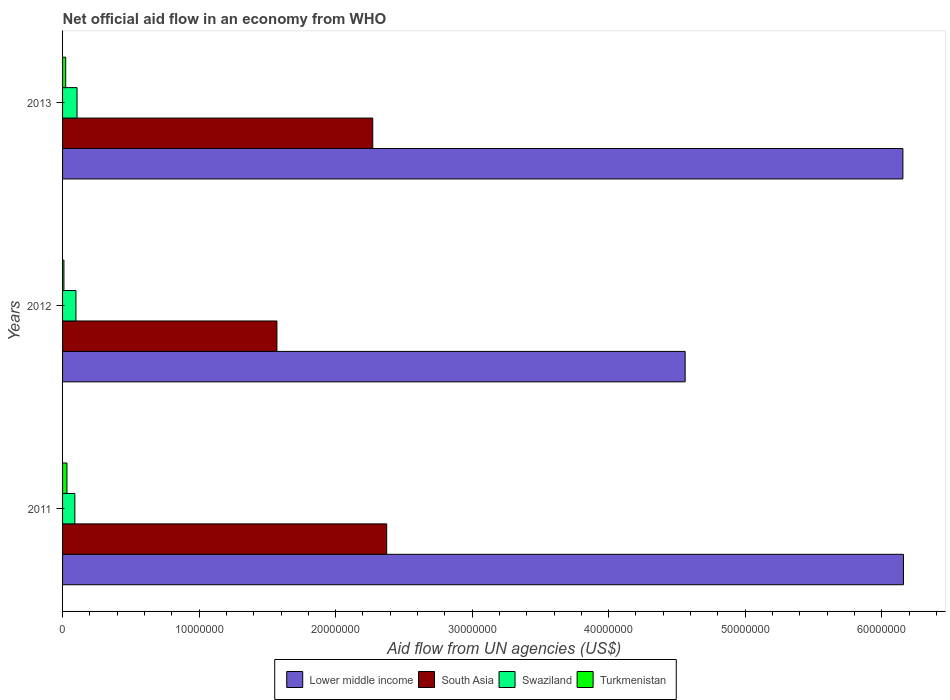How many different coloured bars are there?
Provide a succinct answer. 4. Are the number of bars per tick equal to the number of legend labels?
Make the answer very short. Yes. How many bars are there on the 3rd tick from the top?
Make the answer very short. 4. What is the label of the 3rd group of bars from the top?
Offer a very short reply. 2011. In how many cases, is the number of bars for a given year not equal to the number of legend labels?
Offer a terse response. 0. What is the net official aid flow in Turkmenistan in 2011?
Make the answer very short. 3.20e+05. Across all years, what is the maximum net official aid flow in South Asia?
Your answer should be compact. 2.37e+07. Across all years, what is the minimum net official aid flow in Swaziland?
Your answer should be very brief. 9.00e+05. In which year was the net official aid flow in Lower middle income maximum?
Provide a succinct answer. 2011. In which year was the net official aid flow in Turkmenistan minimum?
Your answer should be compact. 2012. What is the total net official aid flow in Swaziland in the graph?
Ensure brevity in your answer.  2.94e+06. What is the difference between the net official aid flow in South Asia in 2012 and that in 2013?
Your answer should be compact. -7.02e+06. What is the difference between the net official aid flow in South Asia in 2011 and the net official aid flow in Lower middle income in 2012?
Provide a succinct answer. -2.19e+07. What is the average net official aid flow in Swaziland per year?
Keep it short and to the point. 9.80e+05. In the year 2012, what is the difference between the net official aid flow in Swaziland and net official aid flow in Turkmenistan?
Provide a short and direct response. 8.80e+05. What is the ratio of the net official aid flow in Lower middle income in 2011 to that in 2012?
Keep it short and to the point. 1.35. Is the difference between the net official aid flow in Swaziland in 2011 and 2013 greater than the difference between the net official aid flow in Turkmenistan in 2011 and 2013?
Ensure brevity in your answer.  No. Is the sum of the net official aid flow in Turkmenistan in 2011 and 2013 greater than the maximum net official aid flow in Swaziland across all years?
Make the answer very short. No. Is it the case that in every year, the sum of the net official aid flow in Turkmenistan and net official aid flow in Lower middle income is greater than the sum of net official aid flow in Swaziland and net official aid flow in South Asia?
Give a very brief answer. Yes. What does the 2nd bar from the top in 2011 represents?
Offer a terse response. Swaziland. Are all the bars in the graph horizontal?
Your response must be concise. Yes. How many years are there in the graph?
Give a very brief answer. 3. Does the graph contain any zero values?
Keep it short and to the point. No. Does the graph contain grids?
Keep it short and to the point. No. How are the legend labels stacked?
Your answer should be compact. Horizontal. What is the title of the graph?
Give a very brief answer. Net official aid flow in an economy from WHO. Does "Bolivia" appear as one of the legend labels in the graph?
Offer a very short reply. No. What is the label or title of the X-axis?
Offer a very short reply. Aid flow from UN agencies (US$). What is the Aid flow from UN agencies (US$) in Lower middle income in 2011?
Provide a short and direct response. 6.16e+07. What is the Aid flow from UN agencies (US$) in South Asia in 2011?
Your response must be concise. 2.37e+07. What is the Aid flow from UN agencies (US$) in Swaziland in 2011?
Offer a very short reply. 9.00e+05. What is the Aid flow from UN agencies (US$) in Turkmenistan in 2011?
Your answer should be very brief. 3.20e+05. What is the Aid flow from UN agencies (US$) of Lower middle income in 2012?
Your response must be concise. 4.56e+07. What is the Aid flow from UN agencies (US$) in South Asia in 2012?
Provide a short and direct response. 1.57e+07. What is the Aid flow from UN agencies (US$) in Swaziland in 2012?
Provide a succinct answer. 9.80e+05. What is the Aid flow from UN agencies (US$) of Turkmenistan in 2012?
Provide a succinct answer. 1.00e+05. What is the Aid flow from UN agencies (US$) of Lower middle income in 2013?
Your answer should be very brief. 6.16e+07. What is the Aid flow from UN agencies (US$) in South Asia in 2013?
Offer a very short reply. 2.27e+07. What is the Aid flow from UN agencies (US$) in Swaziland in 2013?
Keep it short and to the point. 1.06e+06. What is the Aid flow from UN agencies (US$) of Turkmenistan in 2013?
Offer a terse response. 2.30e+05. Across all years, what is the maximum Aid flow from UN agencies (US$) of Lower middle income?
Your response must be concise. 6.16e+07. Across all years, what is the maximum Aid flow from UN agencies (US$) of South Asia?
Provide a short and direct response. 2.37e+07. Across all years, what is the maximum Aid flow from UN agencies (US$) in Swaziland?
Your answer should be compact. 1.06e+06. Across all years, what is the minimum Aid flow from UN agencies (US$) of Lower middle income?
Your answer should be compact. 4.56e+07. Across all years, what is the minimum Aid flow from UN agencies (US$) of South Asia?
Your response must be concise. 1.57e+07. Across all years, what is the minimum Aid flow from UN agencies (US$) of Swaziland?
Your response must be concise. 9.00e+05. What is the total Aid flow from UN agencies (US$) in Lower middle income in the graph?
Your response must be concise. 1.69e+08. What is the total Aid flow from UN agencies (US$) in South Asia in the graph?
Your answer should be very brief. 6.22e+07. What is the total Aid flow from UN agencies (US$) in Swaziland in the graph?
Your response must be concise. 2.94e+06. What is the total Aid flow from UN agencies (US$) in Turkmenistan in the graph?
Provide a succinct answer. 6.50e+05. What is the difference between the Aid flow from UN agencies (US$) in Lower middle income in 2011 and that in 2012?
Your answer should be very brief. 1.60e+07. What is the difference between the Aid flow from UN agencies (US$) in South Asia in 2011 and that in 2012?
Your answer should be very brief. 8.04e+06. What is the difference between the Aid flow from UN agencies (US$) of Turkmenistan in 2011 and that in 2012?
Provide a succinct answer. 2.20e+05. What is the difference between the Aid flow from UN agencies (US$) of Lower middle income in 2011 and that in 2013?
Your answer should be compact. 4.00e+04. What is the difference between the Aid flow from UN agencies (US$) in South Asia in 2011 and that in 2013?
Your answer should be very brief. 1.02e+06. What is the difference between the Aid flow from UN agencies (US$) in Turkmenistan in 2011 and that in 2013?
Keep it short and to the point. 9.00e+04. What is the difference between the Aid flow from UN agencies (US$) of Lower middle income in 2012 and that in 2013?
Your answer should be very brief. -1.60e+07. What is the difference between the Aid flow from UN agencies (US$) in South Asia in 2012 and that in 2013?
Give a very brief answer. -7.02e+06. What is the difference between the Aid flow from UN agencies (US$) of Swaziland in 2012 and that in 2013?
Ensure brevity in your answer.  -8.00e+04. What is the difference between the Aid flow from UN agencies (US$) of Lower middle income in 2011 and the Aid flow from UN agencies (US$) of South Asia in 2012?
Your answer should be very brief. 4.59e+07. What is the difference between the Aid flow from UN agencies (US$) of Lower middle income in 2011 and the Aid flow from UN agencies (US$) of Swaziland in 2012?
Provide a short and direct response. 6.06e+07. What is the difference between the Aid flow from UN agencies (US$) of Lower middle income in 2011 and the Aid flow from UN agencies (US$) of Turkmenistan in 2012?
Provide a succinct answer. 6.15e+07. What is the difference between the Aid flow from UN agencies (US$) in South Asia in 2011 and the Aid flow from UN agencies (US$) in Swaziland in 2012?
Your answer should be very brief. 2.28e+07. What is the difference between the Aid flow from UN agencies (US$) in South Asia in 2011 and the Aid flow from UN agencies (US$) in Turkmenistan in 2012?
Give a very brief answer. 2.36e+07. What is the difference between the Aid flow from UN agencies (US$) in Lower middle income in 2011 and the Aid flow from UN agencies (US$) in South Asia in 2013?
Ensure brevity in your answer.  3.89e+07. What is the difference between the Aid flow from UN agencies (US$) of Lower middle income in 2011 and the Aid flow from UN agencies (US$) of Swaziland in 2013?
Ensure brevity in your answer.  6.05e+07. What is the difference between the Aid flow from UN agencies (US$) of Lower middle income in 2011 and the Aid flow from UN agencies (US$) of Turkmenistan in 2013?
Provide a short and direct response. 6.14e+07. What is the difference between the Aid flow from UN agencies (US$) in South Asia in 2011 and the Aid flow from UN agencies (US$) in Swaziland in 2013?
Provide a succinct answer. 2.27e+07. What is the difference between the Aid flow from UN agencies (US$) of South Asia in 2011 and the Aid flow from UN agencies (US$) of Turkmenistan in 2013?
Offer a very short reply. 2.35e+07. What is the difference between the Aid flow from UN agencies (US$) of Swaziland in 2011 and the Aid flow from UN agencies (US$) of Turkmenistan in 2013?
Your response must be concise. 6.70e+05. What is the difference between the Aid flow from UN agencies (US$) in Lower middle income in 2012 and the Aid flow from UN agencies (US$) in South Asia in 2013?
Ensure brevity in your answer.  2.29e+07. What is the difference between the Aid flow from UN agencies (US$) of Lower middle income in 2012 and the Aid flow from UN agencies (US$) of Swaziland in 2013?
Provide a short and direct response. 4.45e+07. What is the difference between the Aid flow from UN agencies (US$) in Lower middle income in 2012 and the Aid flow from UN agencies (US$) in Turkmenistan in 2013?
Offer a very short reply. 4.54e+07. What is the difference between the Aid flow from UN agencies (US$) of South Asia in 2012 and the Aid flow from UN agencies (US$) of Swaziland in 2013?
Your answer should be compact. 1.46e+07. What is the difference between the Aid flow from UN agencies (US$) of South Asia in 2012 and the Aid flow from UN agencies (US$) of Turkmenistan in 2013?
Keep it short and to the point. 1.55e+07. What is the difference between the Aid flow from UN agencies (US$) in Swaziland in 2012 and the Aid flow from UN agencies (US$) in Turkmenistan in 2013?
Offer a terse response. 7.50e+05. What is the average Aid flow from UN agencies (US$) in Lower middle income per year?
Ensure brevity in your answer.  5.62e+07. What is the average Aid flow from UN agencies (US$) of South Asia per year?
Offer a very short reply. 2.07e+07. What is the average Aid flow from UN agencies (US$) in Swaziland per year?
Provide a short and direct response. 9.80e+05. What is the average Aid flow from UN agencies (US$) of Turkmenistan per year?
Ensure brevity in your answer.  2.17e+05. In the year 2011, what is the difference between the Aid flow from UN agencies (US$) of Lower middle income and Aid flow from UN agencies (US$) of South Asia?
Keep it short and to the point. 3.78e+07. In the year 2011, what is the difference between the Aid flow from UN agencies (US$) of Lower middle income and Aid flow from UN agencies (US$) of Swaziland?
Keep it short and to the point. 6.07e+07. In the year 2011, what is the difference between the Aid flow from UN agencies (US$) in Lower middle income and Aid flow from UN agencies (US$) in Turkmenistan?
Offer a very short reply. 6.13e+07. In the year 2011, what is the difference between the Aid flow from UN agencies (US$) of South Asia and Aid flow from UN agencies (US$) of Swaziland?
Keep it short and to the point. 2.28e+07. In the year 2011, what is the difference between the Aid flow from UN agencies (US$) of South Asia and Aid flow from UN agencies (US$) of Turkmenistan?
Give a very brief answer. 2.34e+07. In the year 2011, what is the difference between the Aid flow from UN agencies (US$) in Swaziland and Aid flow from UN agencies (US$) in Turkmenistan?
Make the answer very short. 5.80e+05. In the year 2012, what is the difference between the Aid flow from UN agencies (US$) in Lower middle income and Aid flow from UN agencies (US$) in South Asia?
Offer a very short reply. 2.99e+07. In the year 2012, what is the difference between the Aid flow from UN agencies (US$) in Lower middle income and Aid flow from UN agencies (US$) in Swaziland?
Ensure brevity in your answer.  4.46e+07. In the year 2012, what is the difference between the Aid flow from UN agencies (US$) in Lower middle income and Aid flow from UN agencies (US$) in Turkmenistan?
Your answer should be very brief. 4.55e+07. In the year 2012, what is the difference between the Aid flow from UN agencies (US$) of South Asia and Aid flow from UN agencies (US$) of Swaziland?
Your response must be concise. 1.47e+07. In the year 2012, what is the difference between the Aid flow from UN agencies (US$) in South Asia and Aid flow from UN agencies (US$) in Turkmenistan?
Provide a short and direct response. 1.56e+07. In the year 2012, what is the difference between the Aid flow from UN agencies (US$) of Swaziland and Aid flow from UN agencies (US$) of Turkmenistan?
Provide a succinct answer. 8.80e+05. In the year 2013, what is the difference between the Aid flow from UN agencies (US$) of Lower middle income and Aid flow from UN agencies (US$) of South Asia?
Keep it short and to the point. 3.88e+07. In the year 2013, what is the difference between the Aid flow from UN agencies (US$) in Lower middle income and Aid flow from UN agencies (US$) in Swaziland?
Provide a succinct answer. 6.05e+07. In the year 2013, what is the difference between the Aid flow from UN agencies (US$) of Lower middle income and Aid flow from UN agencies (US$) of Turkmenistan?
Provide a succinct answer. 6.13e+07. In the year 2013, what is the difference between the Aid flow from UN agencies (US$) in South Asia and Aid flow from UN agencies (US$) in Swaziland?
Provide a succinct answer. 2.17e+07. In the year 2013, what is the difference between the Aid flow from UN agencies (US$) in South Asia and Aid flow from UN agencies (US$) in Turkmenistan?
Your response must be concise. 2.25e+07. In the year 2013, what is the difference between the Aid flow from UN agencies (US$) of Swaziland and Aid flow from UN agencies (US$) of Turkmenistan?
Offer a very short reply. 8.30e+05. What is the ratio of the Aid flow from UN agencies (US$) in Lower middle income in 2011 to that in 2012?
Offer a very short reply. 1.35. What is the ratio of the Aid flow from UN agencies (US$) in South Asia in 2011 to that in 2012?
Offer a very short reply. 1.51. What is the ratio of the Aid flow from UN agencies (US$) of Swaziland in 2011 to that in 2012?
Ensure brevity in your answer.  0.92. What is the ratio of the Aid flow from UN agencies (US$) in Turkmenistan in 2011 to that in 2012?
Make the answer very short. 3.2. What is the ratio of the Aid flow from UN agencies (US$) in South Asia in 2011 to that in 2013?
Your response must be concise. 1.04. What is the ratio of the Aid flow from UN agencies (US$) of Swaziland in 2011 to that in 2013?
Keep it short and to the point. 0.85. What is the ratio of the Aid flow from UN agencies (US$) of Turkmenistan in 2011 to that in 2013?
Offer a terse response. 1.39. What is the ratio of the Aid flow from UN agencies (US$) in Lower middle income in 2012 to that in 2013?
Ensure brevity in your answer.  0.74. What is the ratio of the Aid flow from UN agencies (US$) in South Asia in 2012 to that in 2013?
Give a very brief answer. 0.69. What is the ratio of the Aid flow from UN agencies (US$) of Swaziland in 2012 to that in 2013?
Give a very brief answer. 0.92. What is the ratio of the Aid flow from UN agencies (US$) of Turkmenistan in 2012 to that in 2013?
Make the answer very short. 0.43. What is the difference between the highest and the second highest Aid flow from UN agencies (US$) of Lower middle income?
Your answer should be very brief. 4.00e+04. What is the difference between the highest and the second highest Aid flow from UN agencies (US$) in South Asia?
Ensure brevity in your answer.  1.02e+06. What is the difference between the highest and the second highest Aid flow from UN agencies (US$) of Swaziland?
Offer a very short reply. 8.00e+04. What is the difference between the highest and the second highest Aid flow from UN agencies (US$) of Turkmenistan?
Keep it short and to the point. 9.00e+04. What is the difference between the highest and the lowest Aid flow from UN agencies (US$) of Lower middle income?
Give a very brief answer. 1.60e+07. What is the difference between the highest and the lowest Aid flow from UN agencies (US$) in South Asia?
Provide a succinct answer. 8.04e+06. What is the difference between the highest and the lowest Aid flow from UN agencies (US$) of Swaziland?
Your answer should be compact. 1.60e+05. 